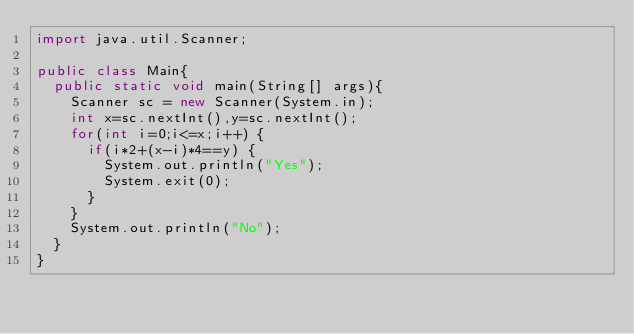Convert code to text. <code><loc_0><loc_0><loc_500><loc_500><_Java_>import java.util.Scanner;

public class Main{
  public static void main(String[] args){
	  Scanner sc = new Scanner(System.in);
	  int x=sc.nextInt(),y=sc.nextInt();
	  for(int i=0;i<=x;i++) {
		  if(i*2+(x-i)*4==y) {
			  System.out.println("Yes");
			  System.exit(0);
		  }
	  }
	  System.out.println("No");
  }
}

</code> 